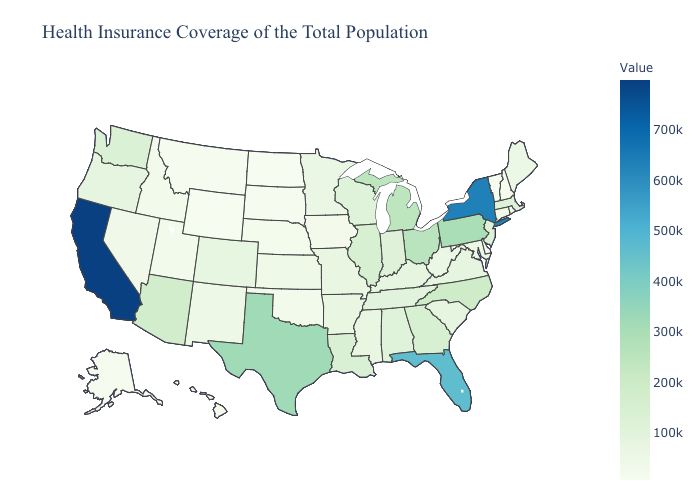Does Iowa have a lower value than California?
Be succinct. Yes. Among the states that border Nebraska , which have the highest value?
Be succinct. Colorado. Which states have the lowest value in the Northeast?
Write a very short answer. Vermont. Among the states that border Nevada , which have the highest value?
Concise answer only. California. Does Washington have a higher value than Utah?
Give a very brief answer. Yes. 